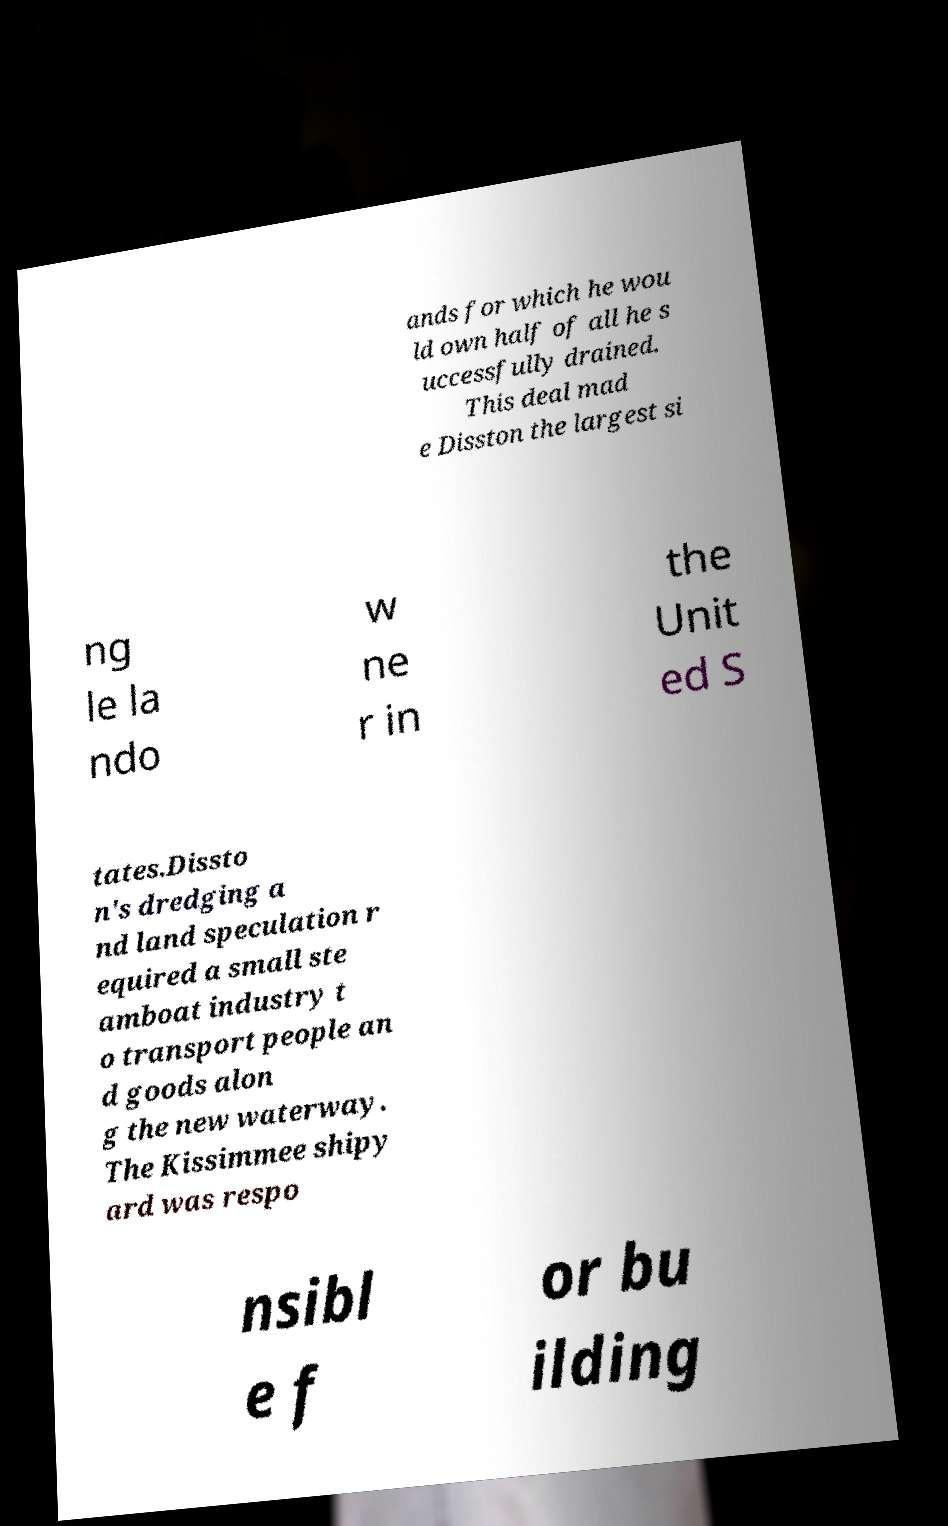What messages or text are displayed in this image? I need them in a readable, typed format. ands for which he wou ld own half of all he s uccessfully drained. This deal mad e Disston the largest si ng le la ndo w ne r in the Unit ed S tates.Dissto n's dredging a nd land speculation r equired a small ste amboat industry t o transport people an d goods alon g the new waterway. The Kissimmee shipy ard was respo nsibl e f or bu ilding 